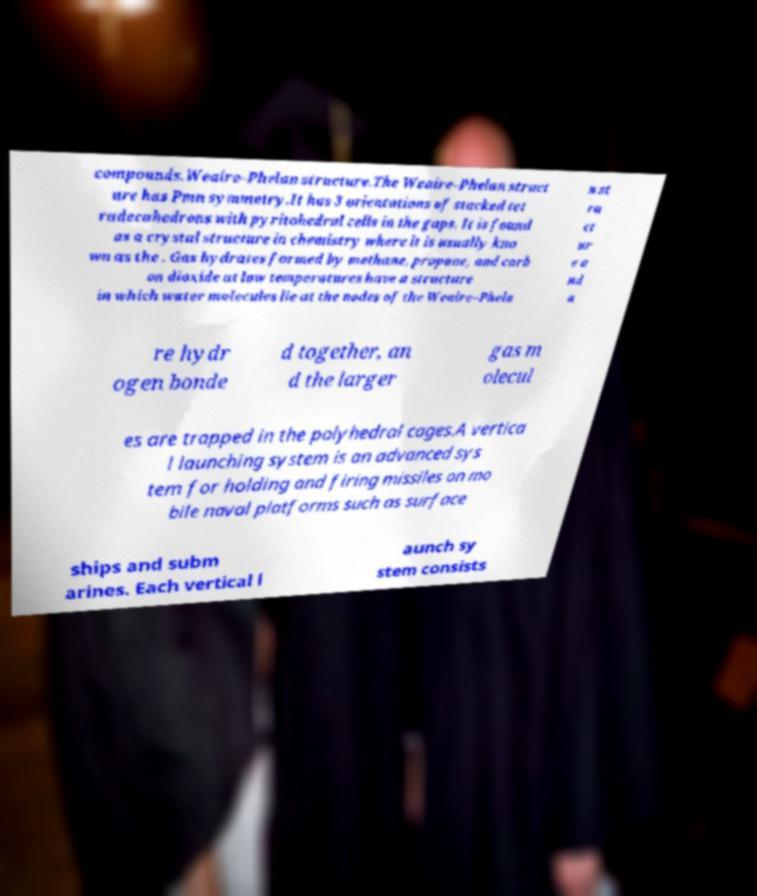I need the written content from this picture converted into text. Can you do that? compounds.Weaire–Phelan structure.The Weaire–Phelan struct ure has Pmn symmetry.It has 3 orientations of stacked tet radecahedrons with pyritohedral cells in the gaps. It is found as a crystal structure in chemistry where it is usually kno wn as the . Gas hydrates formed by methane, propane, and carb on dioxide at low temperatures have a structure in which water molecules lie at the nodes of the Weaire–Phela n st ru ct ur e a nd a re hydr ogen bonde d together, an d the larger gas m olecul es are trapped in the polyhedral cages.A vertica l launching system is an advanced sys tem for holding and firing missiles on mo bile naval platforms such as surface ships and subm arines. Each vertical l aunch sy stem consists 